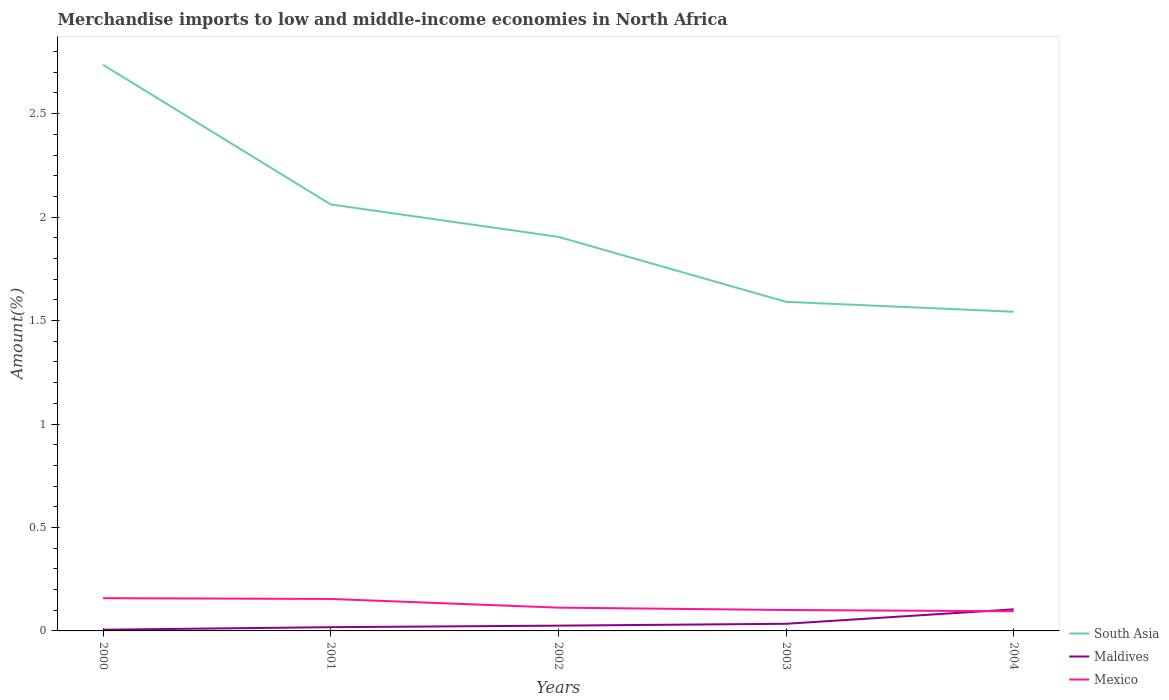How many different coloured lines are there?
Offer a very short reply. 3. Does the line corresponding to Mexico intersect with the line corresponding to Maldives?
Keep it short and to the point. Yes. Across all years, what is the maximum percentage of amount earned from merchandise imports in South Asia?
Your response must be concise. 1.54. In which year was the percentage of amount earned from merchandise imports in Maldives maximum?
Offer a very short reply. 2000. What is the total percentage of amount earned from merchandise imports in Mexico in the graph?
Ensure brevity in your answer.  0.06. What is the difference between the highest and the second highest percentage of amount earned from merchandise imports in Maldives?
Offer a terse response. 0.1. What is the difference between the highest and the lowest percentage of amount earned from merchandise imports in Mexico?
Ensure brevity in your answer.  2. Is the percentage of amount earned from merchandise imports in Mexico strictly greater than the percentage of amount earned from merchandise imports in Maldives over the years?
Offer a terse response. No. How many years are there in the graph?
Your answer should be compact. 5. Are the values on the major ticks of Y-axis written in scientific E-notation?
Give a very brief answer. No. Does the graph contain any zero values?
Ensure brevity in your answer.  No. Where does the legend appear in the graph?
Your response must be concise. Bottom right. How many legend labels are there?
Give a very brief answer. 3. What is the title of the graph?
Your response must be concise. Merchandise imports to low and middle-income economies in North Africa. What is the label or title of the X-axis?
Offer a very short reply. Years. What is the label or title of the Y-axis?
Offer a very short reply. Amount(%). What is the Amount(%) in South Asia in 2000?
Your answer should be compact. 2.74. What is the Amount(%) of Maldives in 2000?
Provide a short and direct response. 0.01. What is the Amount(%) in Mexico in 2000?
Give a very brief answer. 0.16. What is the Amount(%) in South Asia in 2001?
Make the answer very short. 2.06. What is the Amount(%) of Maldives in 2001?
Offer a very short reply. 0.02. What is the Amount(%) in Mexico in 2001?
Give a very brief answer. 0.15. What is the Amount(%) in South Asia in 2002?
Provide a short and direct response. 1.9. What is the Amount(%) of Maldives in 2002?
Your answer should be compact. 0.03. What is the Amount(%) in Mexico in 2002?
Make the answer very short. 0.11. What is the Amount(%) of South Asia in 2003?
Offer a terse response. 1.59. What is the Amount(%) of Maldives in 2003?
Keep it short and to the point. 0.03. What is the Amount(%) in Mexico in 2003?
Your response must be concise. 0.1. What is the Amount(%) of South Asia in 2004?
Your answer should be very brief. 1.54. What is the Amount(%) in Maldives in 2004?
Give a very brief answer. 0.1. What is the Amount(%) of Mexico in 2004?
Ensure brevity in your answer.  0.1. Across all years, what is the maximum Amount(%) of South Asia?
Your answer should be very brief. 2.74. Across all years, what is the maximum Amount(%) in Maldives?
Make the answer very short. 0.1. Across all years, what is the maximum Amount(%) of Mexico?
Your answer should be compact. 0.16. Across all years, what is the minimum Amount(%) in South Asia?
Keep it short and to the point. 1.54. Across all years, what is the minimum Amount(%) of Maldives?
Keep it short and to the point. 0.01. Across all years, what is the minimum Amount(%) of Mexico?
Ensure brevity in your answer.  0.1. What is the total Amount(%) of South Asia in the graph?
Ensure brevity in your answer.  9.83. What is the total Amount(%) of Maldives in the graph?
Make the answer very short. 0.19. What is the total Amount(%) in Mexico in the graph?
Make the answer very short. 0.62. What is the difference between the Amount(%) of South Asia in 2000 and that in 2001?
Make the answer very short. 0.67. What is the difference between the Amount(%) in Maldives in 2000 and that in 2001?
Provide a succinct answer. -0.01. What is the difference between the Amount(%) in Mexico in 2000 and that in 2001?
Your response must be concise. 0. What is the difference between the Amount(%) of South Asia in 2000 and that in 2002?
Your response must be concise. 0.83. What is the difference between the Amount(%) in Maldives in 2000 and that in 2002?
Offer a terse response. -0.02. What is the difference between the Amount(%) in Mexico in 2000 and that in 2002?
Offer a very short reply. 0.05. What is the difference between the Amount(%) of South Asia in 2000 and that in 2003?
Keep it short and to the point. 1.15. What is the difference between the Amount(%) of Maldives in 2000 and that in 2003?
Offer a very short reply. -0.03. What is the difference between the Amount(%) in Mexico in 2000 and that in 2003?
Offer a terse response. 0.06. What is the difference between the Amount(%) of South Asia in 2000 and that in 2004?
Offer a very short reply. 1.19. What is the difference between the Amount(%) in Maldives in 2000 and that in 2004?
Offer a very short reply. -0.1. What is the difference between the Amount(%) of Mexico in 2000 and that in 2004?
Ensure brevity in your answer.  0.06. What is the difference between the Amount(%) of South Asia in 2001 and that in 2002?
Your answer should be compact. 0.16. What is the difference between the Amount(%) in Maldives in 2001 and that in 2002?
Keep it short and to the point. -0.01. What is the difference between the Amount(%) in Mexico in 2001 and that in 2002?
Give a very brief answer. 0.04. What is the difference between the Amount(%) of South Asia in 2001 and that in 2003?
Give a very brief answer. 0.47. What is the difference between the Amount(%) in Maldives in 2001 and that in 2003?
Offer a very short reply. -0.02. What is the difference between the Amount(%) in Mexico in 2001 and that in 2003?
Offer a terse response. 0.05. What is the difference between the Amount(%) in South Asia in 2001 and that in 2004?
Offer a terse response. 0.52. What is the difference between the Amount(%) of Maldives in 2001 and that in 2004?
Provide a short and direct response. -0.09. What is the difference between the Amount(%) in Mexico in 2001 and that in 2004?
Offer a terse response. 0.06. What is the difference between the Amount(%) in South Asia in 2002 and that in 2003?
Your answer should be very brief. 0.31. What is the difference between the Amount(%) of Maldives in 2002 and that in 2003?
Offer a very short reply. -0.01. What is the difference between the Amount(%) in Mexico in 2002 and that in 2003?
Provide a succinct answer. 0.01. What is the difference between the Amount(%) in South Asia in 2002 and that in 2004?
Your response must be concise. 0.36. What is the difference between the Amount(%) in Maldives in 2002 and that in 2004?
Provide a short and direct response. -0.08. What is the difference between the Amount(%) of Mexico in 2002 and that in 2004?
Your answer should be very brief. 0.02. What is the difference between the Amount(%) of South Asia in 2003 and that in 2004?
Provide a short and direct response. 0.05. What is the difference between the Amount(%) in Maldives in 2003 and that in 2004?
Provide a short and direct response. -0.07. What is the difference between the Amount(%) in Mexico in 2003 and that in 2004?
Keep it short and to the point. 0.01. What is the difference between the Amount(%) of South Asia in 2000 and the Amount(%) of Maldives in 2001?
Offer a very short reply. 2.72. What is the difference between the Amount(%) of South Asia in 2000 and the Amount(%) of Mexico in 2001?
Make the answer very short. 2.58. What is the difference between the Amount(%) in Maldives in 2000 and the Amount(%) in Mexico in 2001?
Your answer should be very brief. -0.15. What is the difference between the Amount(%) in South Asia in 2000 and the Amount(%) in Maldives in 2002?
Your answer should be compact. 2.71. What is the difference between the Amount(%) of South Asia in 2000 and the Amount(%) of Mexico in 2002?
Make the answer very short. 2.62. What is the difference between the Amount(%) in Maldives in 2000 and the Amount(%) in Mexico in 2002?
Make the answer very short. -0.11. What is the difference between the Amount(%) in South Asia in 2000 and the Amount(%) in Maldives in 2003?
Provide a short and direct response. 2.7. What is the difference between the Amount(%) in South Asia in 2000 and the Amount(%) in Mexico in 2003?
Provide a short and direct response. 2.63. What is the difference between the Amount(%) in Maldives in 2000 and the Amount(%) in Mexico in 2003?
Keep it short and to the point. -0.1. What is the difference between the Amount(%) in South Asia in 2000 and the Amount(%) in Maldives in 2004?
Make the answer very short. 2.63. What is the difference between the Amount(%) of South Asia in 2000 and the Amount(%) of Mexico in 2004?
Provide a short and direct response. 2.64. What is the difference between the Amount(%) of Maldives in 2000 and the Amount(%) of Mexico in 2004?
Provide a succinct answer. -0.09. What is the difference between the Amount(%) in South Asia in 2001 and the Amount(%) in Maldives in 2002?
Keep it short and to the point. 2.04. What is the difference between the Amount(%) in South Asia in 2001 and the Amount(%) in Mexico in 2002?
Your answer should be compact. 1.95. What is the difference between the Amount(%) in Maldives in 2001 and the Amount(%) in Mexico in 2002?
Ensure brevity in your answer.  -0.09. What is the difference between the Amount(%) in South Asia in 2001 and the Amount(%) in Maldives in 2003?
Offer a very short reply. 2.03. What is the difference between the Amount(%) of South Asia in 2001 and the Amount(%) of Mexico in 2003?
Offer a terse response. 1.96. What is the difference between the Amount(%) in Maldives in 2001 and the Amount(%) in Mexico in 2003?
Offer a terse response. -0.08. What is the difference between the Amount(%) in South Asia in 2001 and the Amount(%) in Maldives in 2004?
Make the answer very short. 1.96. What is the difference between the Amount(%) in South Asia in 2001 and the Amount(%) in Mexico in 2004?
Provide a succinct answer. 1.97. What is the difference between the Amount(%) of Maldives in 2001 and the Amount(%) of Mexico in 2004?
Provide a succinct answer. -0.08. What is the difference between the Amount(%) in South Asia in 2002 and the Amount(%) in Maldives in 2003?
Provide a succinct answer. 1.87. What is the difference between the Amount(%) of South Asia in 2002 and the Amount(%) of Mexico in 2003?
Make the answer very short. 1.8. What is the difference between the Amount(%) of Maldives in 2002 and the Amount(%) of Mexico in 2003?
Offer a terse response. -0.08. What is the difference between the Amount(%) of South Asia in 2002 and the Amount(%) of Maldives in 2004?
Offer a very short reply. 1.8. What is the difference between the Amount(%) in South Asia in 2002 and the Amount(%) in Mexico in 2004?
Provide a short and direct response. 1.81. What is the difference between the Amount(%) in Maldives in 2002 and the Amount(%) in Mexico in 2004?
Ensure brevity in your answer.  -0.07. What is the difference between the Amount(%) in South Asia in 2003 and the Amount(%) in Maldives in 2004?
Your response must be concise. 1.49. What is the difference between the Amount(%) in South Asia in 2003 and the Amount(%) in Mexico in 2004?
Your answer should be very brief. 1.5. What is the difference between the Amount(%) in Maldives in 2003 and the Amount(%) in Mexico in 2004?
Provide a short and direct response. -0.06. What is the average Amount(%) of South Asia per year?
Ensure brevity in your answer.  1.97. What is the average Amount(%) in Maldives per year?
Your answer should be very brief. 0.04. What is the average Amount(%) of Mexico per year?
Give a very brief answer. 0.12. In the year 2000, what is the difference between the Amount(%) of South Asia and Amount(%) of Maldives?
Keep it short and to the point. 2.73. In the year 2000, what is the difference between the Amount(%) of South Asia and Amount(%) of Mexico?
Give a very brief answer. 2.58. In the year 2000, what is the difference between the Amount(%) of Maldives and Amount(%) of Mexico?
Provide a short and direct response. -0.15. In the year 2001, what is the difference between the Amount(%) of South Asia and Amount(%) of Maldives?
Provide a succinct answer. 2.04. In the year 2001, what is the difference between the Amount(%) of South Asia and Amount(%) of Mexico?
Your answer should be very brief. 1.91. In the year 2001, what is the difference between the Amount(%) of Maldives and Amount(%) of Mexico?
Your answer should be compact. -0.14. In the year 2002, what is the difference between the Amount(%) in South Asia and Amount(%) in Maldives?
Offer a very short reply. 1.88. In the year 2002, what is the difference between the Amount(%) in South Asia and Amount(%) in Mexico?
Offer a terse response. 1.79. In the year 2002, what is the difference between the Amount(%) of Maldives and Amount(%) of Mexico?
Give a very brief answer. -0.09. In the year 2003, what is the difference between the Amount(%) of South Asia and Amount(%) of Maldives?
Keep it short and to the point. 1.56. In the year 2003, what is the difference between the Amount(%) in South Asia and Amount(%) in Mexico?
Ensure brevity in your answer.  1.49. In the year 2003, what is the difference between the Amount(%) of Maldives and Amount(%) of Mexico?
Offer a terse response. -0.07. In the year 2004, what is the difference between the Amount(%) in South Asia and Amount(%) in Maldives?
Keep it short and to the point. 1.44. In the year 2004, what is the difference between the Amount(%) of South Asia and Amount(%) of Mexico?
Your answer should be compact. 1.45. In the year 2004, what is the difference between the Amount(%) of Maldives and Amount(%) of Mexico?
Offer a very short reply. 0.01. What is the ratio of the Amount(%) in South Asia in 2000 to that in 2001?
Keep it short and to the point. 1.33. What is the ratio of the Amount(%) of Maldives in 2000 to that in 2001?
Your response must be concise. 0.32. What is the ratio of the Amount(%) in Mexico in 2000 to that in 2001?
Provide a short and direct response. 1.02. What is the ratio of the Amount(%) in South Asia in 2000 to that in 2002?
Provide a short and direct response. 1.44. What is the ratio of the Amount(%) in Maldives in 2000 to that in 2002?
Keep it short and to the point. 0.23. What is the ratio of the Amount(%) in Mexico in 2000 to that in 2002?
Provide a short and direct response. 1.41. What is the ratio of the Amount(%) in South Asia in 2000 to that in 2003?
Make the answer very short. 1.72. What is the ratio of the Amount(%) of Maldives in 2000 to that in 2003?
Give a very brief answer. 0.17. What is the ratio of the Amount(%) in Mexico in 2000 to that in 2003?
Your answer should be compact. 1.56. What is the ratio of the Amount(%) in South Asia in 2000 to that in 2004?
Keep it short and to the point. 1.77. What is the ratio of the Amount(%) of Maldives in 2000 to that in 2004?
Provide a short and direct response. 0.06. What is the ratio of the Amount(%) of Mexico in 2000 to that in 2004?
Offer a very short reply. 1.66. What is the ratio of the Amount(%) of South Asia in 2001 to that in 2002?
Ensure brevity in your answer.  1.08. What is the ratio of the Amount(%) in Maldives in 2001 to that in 2002?
Make the answer very short. 0.71. What is the ratio of the Amount(%) in Mexico in 2001 to that in 2002?
Your answer should be very brief. 1.37. What is the ratio of the Amount(%) of South Asia in 2001 to that in 2003?
Your answer should be very brief. 1.3. What is the ratio of the Amount(%) of Maldives in 2001 to that in 2003?
Ensure brevity in your answer.  0.53. What is the ratio of the Amount(%) in Mexico in 2001 to that in 2003?
Your response must be concise. 1.53. What is the ratio of the Amount(%) of South Asia in 2001 to that in 2004?
Offer a terse response. 1.34. What is the ratio of the Amount(%) of Maldives in 2001 to that in 2004?
Offer a very short reply. 0.17. What is the ratio of the Amount(%) in Mexico in 2001 to that in 2004?
Ensure brevity in your answer.  1.62. What is the ratio of the Amount(%) of South Asia in 2002 to that in 2003?
Your answer should be compact. 1.2. What is the ratio of the Amount(%) of Maldives in 2002 to that in 2003?
Provide a succinct answer. 0.74. What is the ratio of the Amount(%) of Mexico in 2002 to that in 2003?
Provide a succinct answer. 1.11. What is the ratio of the Amount(%) in South Asia in 2002 to that in 2004?
Keep it short and to the point. 1.23. What is the ratio of the Amount(%) in Maldives in 2002 to that in 2004?
Your answer should be very brief. 0.24. What is the ratio of the Amount(%) in Mexico in 2002 to that in 2004?
Make the answer very short. 1.18. What is the ratio of the Amount(%) of South Asia in 2003 to that in 2004?
Offer a very short reply. 1.03. What is the ratio of the Amount(%) in Maldives in 2003 to that in 2004?
Provide a succinct answer. 0.33. What is the ratio of the Amount(%) of Mexico in 2003 to that in 2004?
Your answer should be compact. 1.06. What is the difference between the highest and the second highest Amount(%) of South Asia?
Offer a terse response. 0.67. What is the difference between the highest and the second highest Amount(%) of Maldives?
Provide a succinct answer. 0.07. What is the difference between the highest and the second highest Amount(%) of Mexico?
Give a very brief answer. 0. What is the difference between the highest and the lowest Amount(%) of South Asia?
Ensure brevity in your answer.  1.19. What is the difference between the highest and the lowest Amount(%) in Maldives?
Make the answer very short. 0.1. What is the difference between the highest and the lowest Amount(%) of Mexico?
Provide a short and direct response. 0.06. 